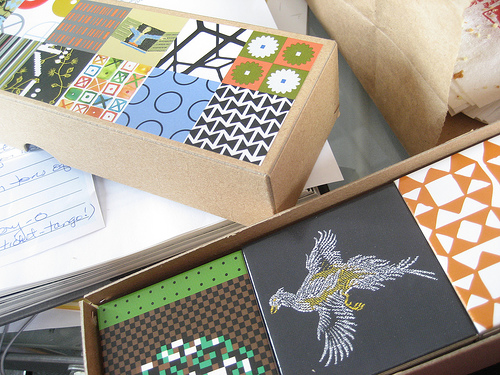<image>
Is the paper in the box? No. The paper is not contained within the box. These objects have a different spatial relationship. 